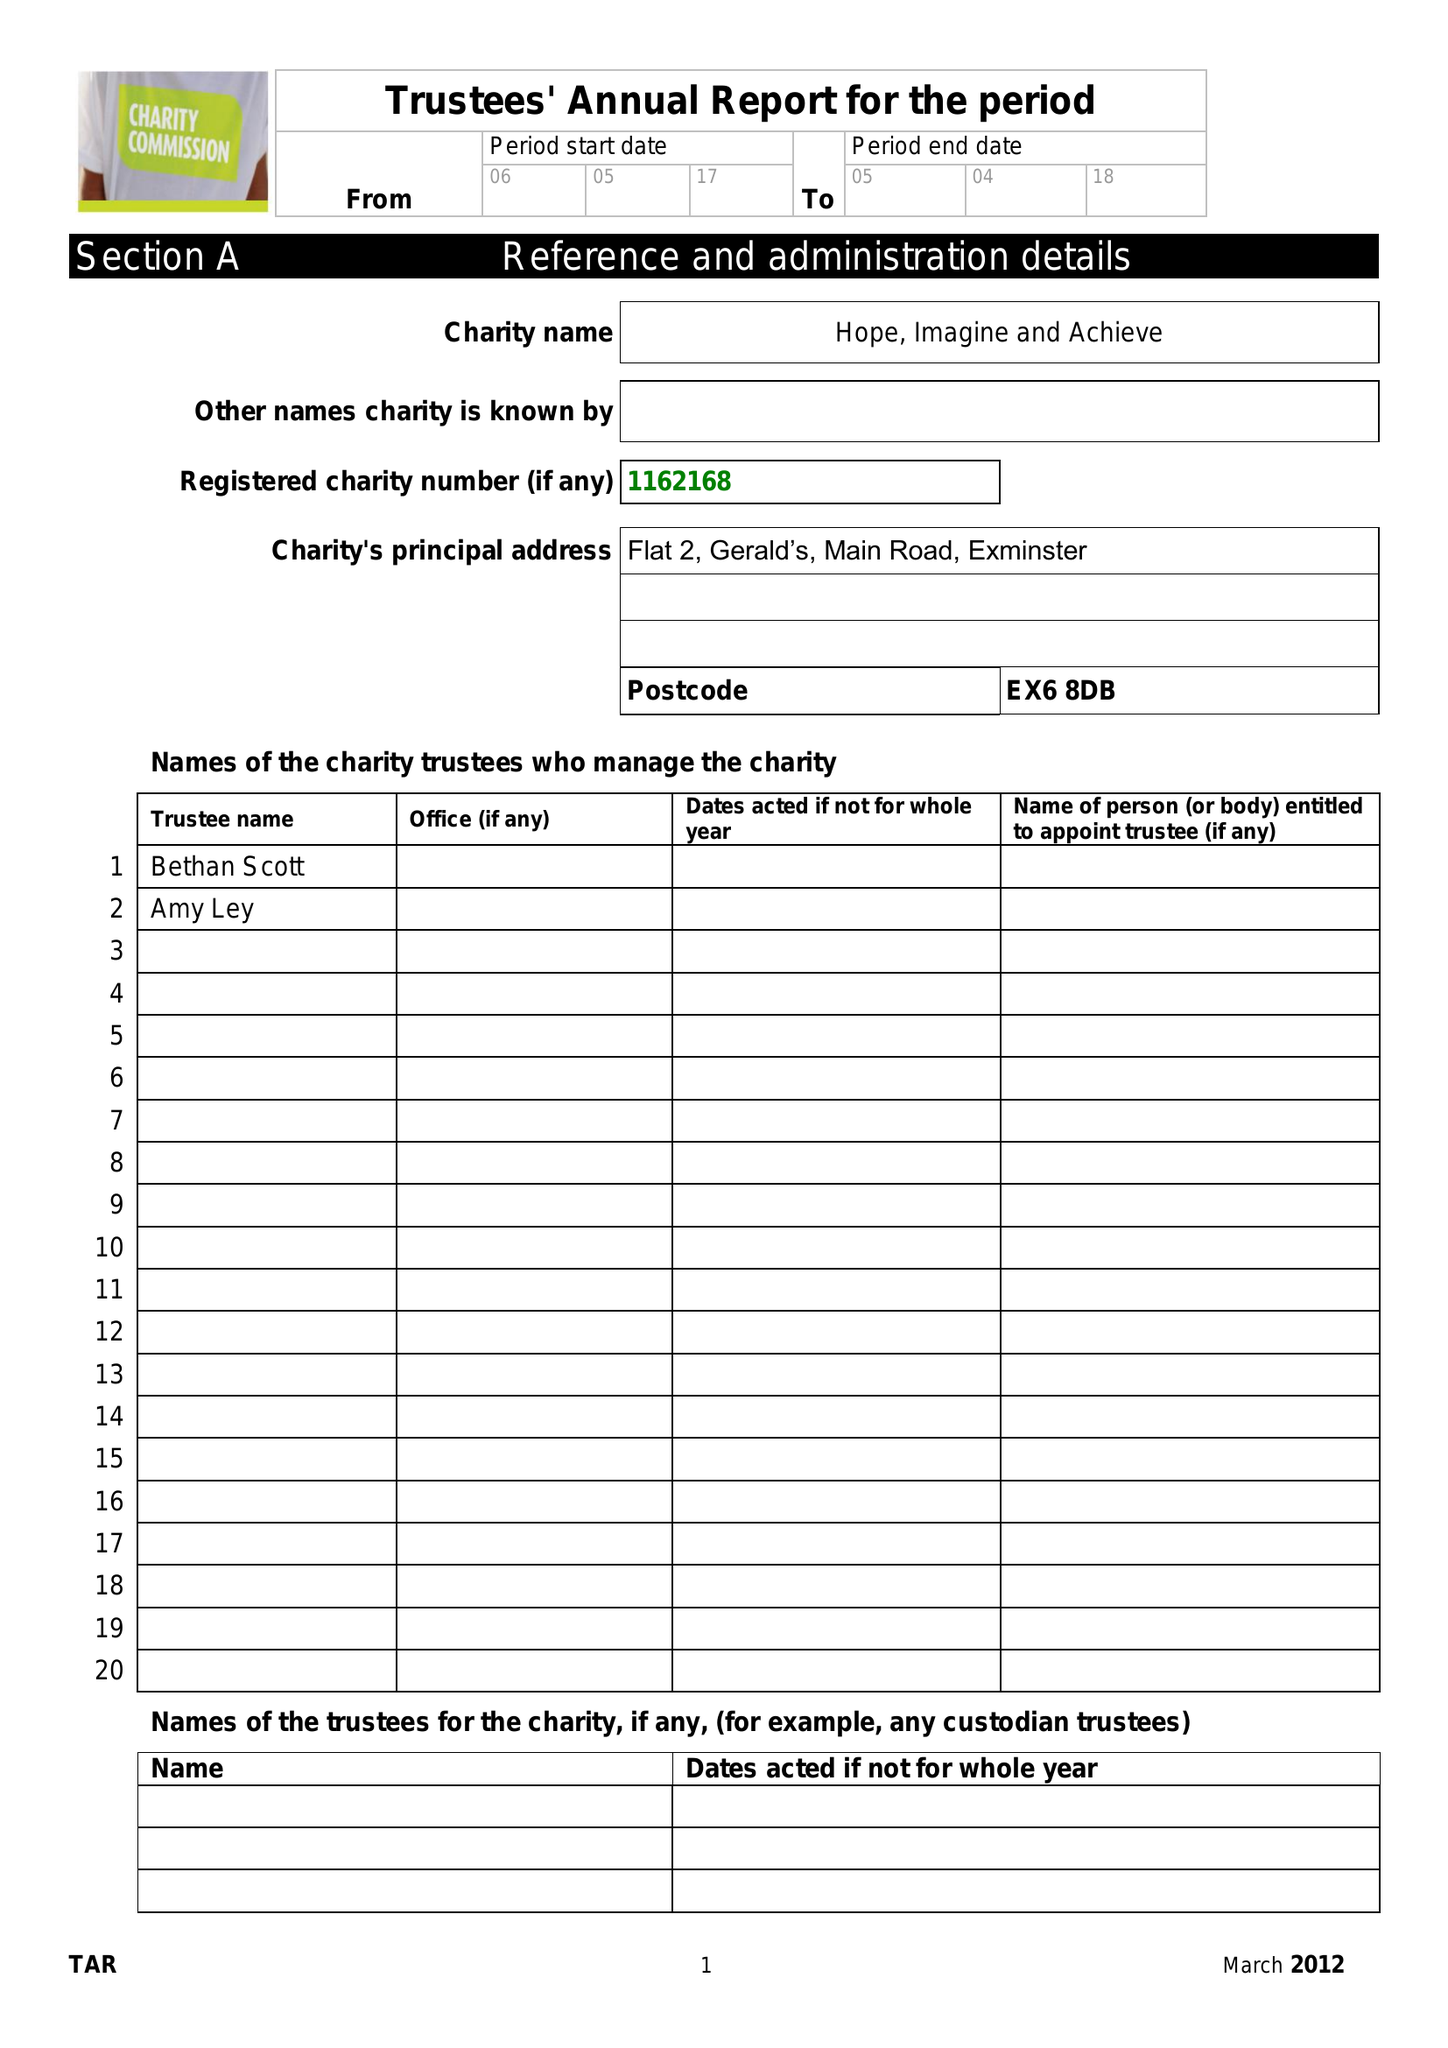What is the value for the address__postcode?
Answer the question using a single word or phrase. EX6 8DB 